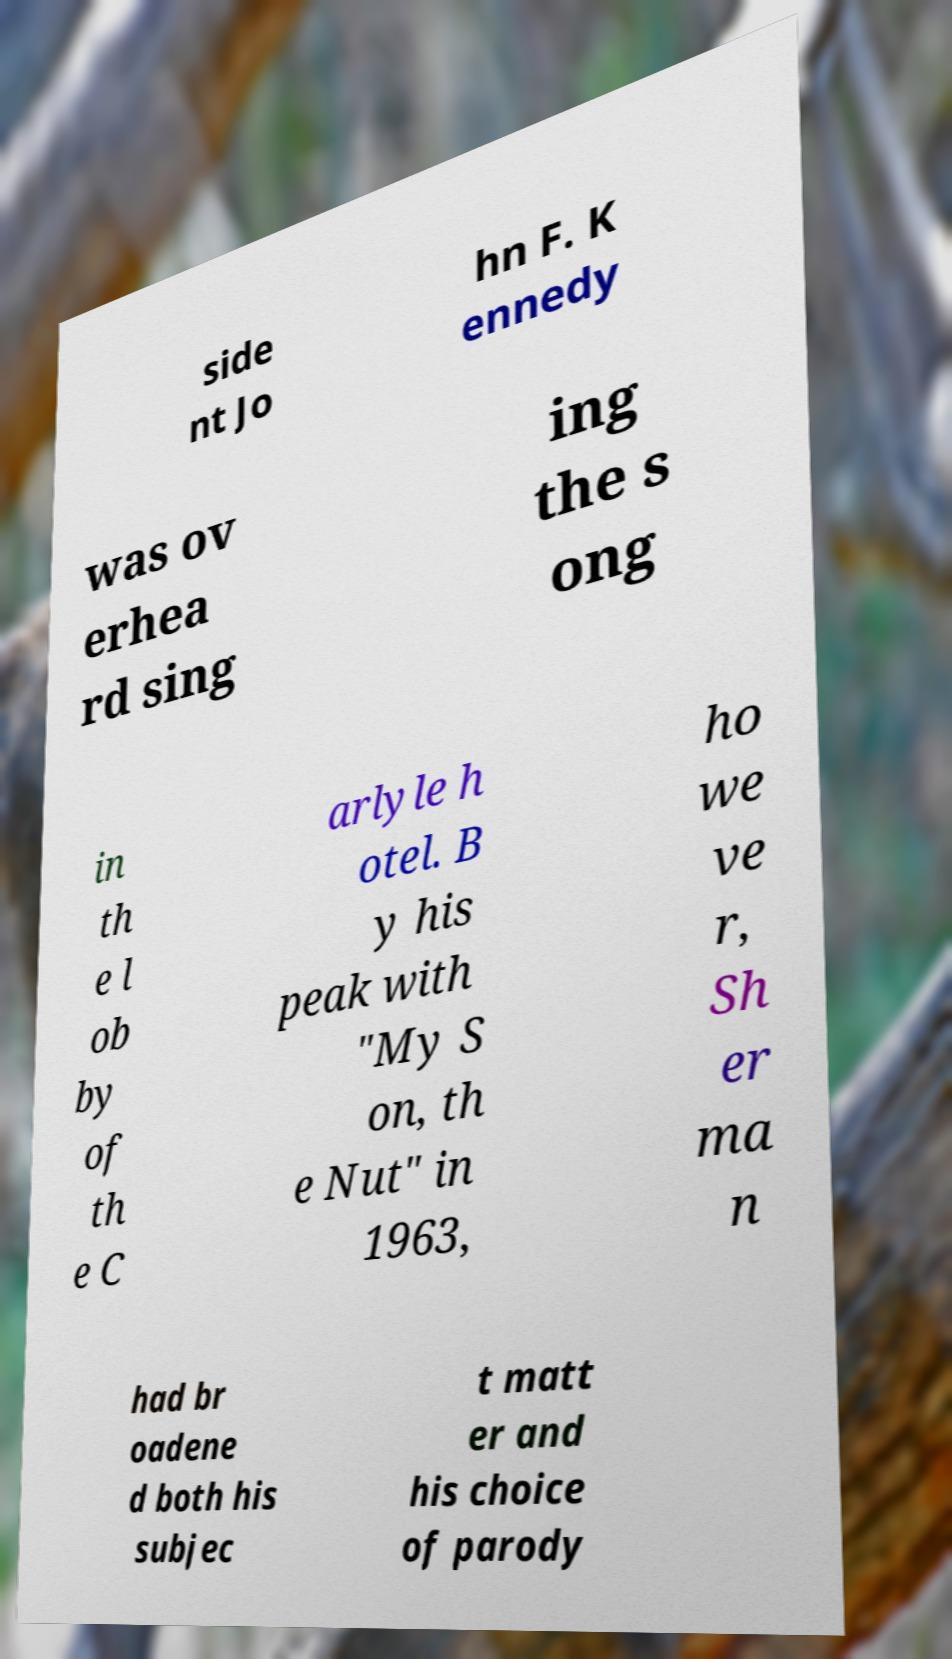What messages or text are displayed in this image? I need them in a readable, typed format. side nt Jo hn F. K ennedy was ov erhea rd sing ing the s ong in th e l ob by of th e C arlyle h otel. B y his peak with "My S on, th e Nut" in 1963, ho we ve r, Sh er ma n had br oadene d both his subjec t matt er and his choice of parody 